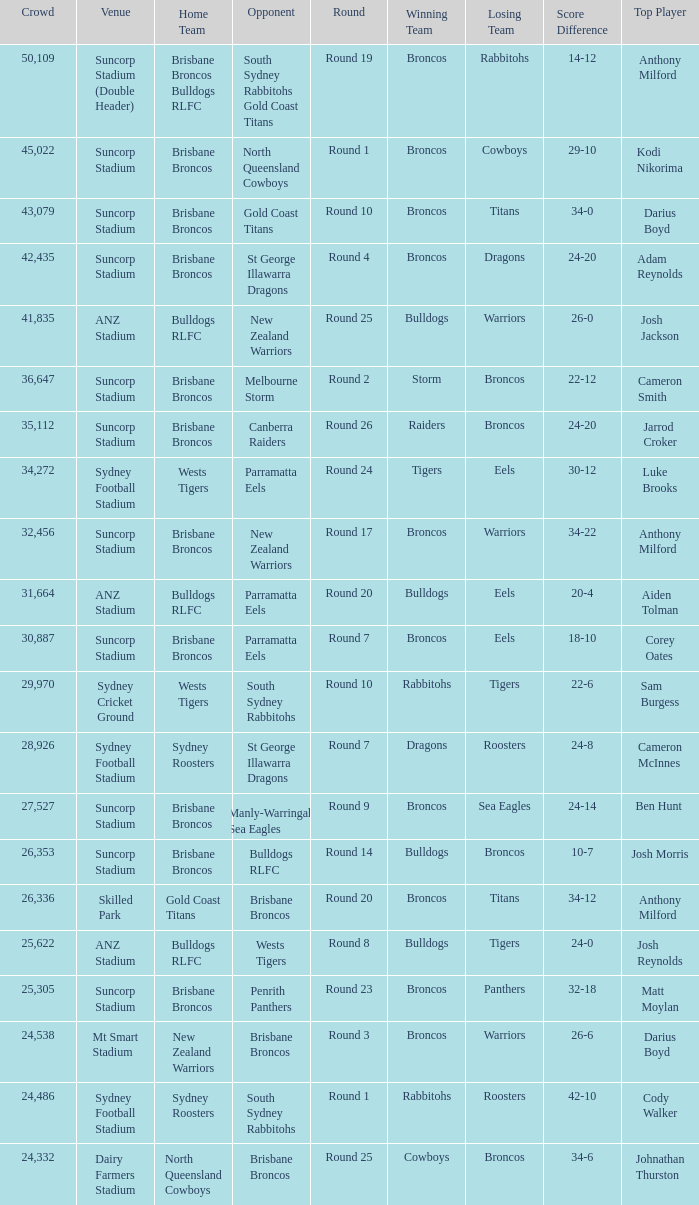What was the attendance at Round 9? 1.0. 